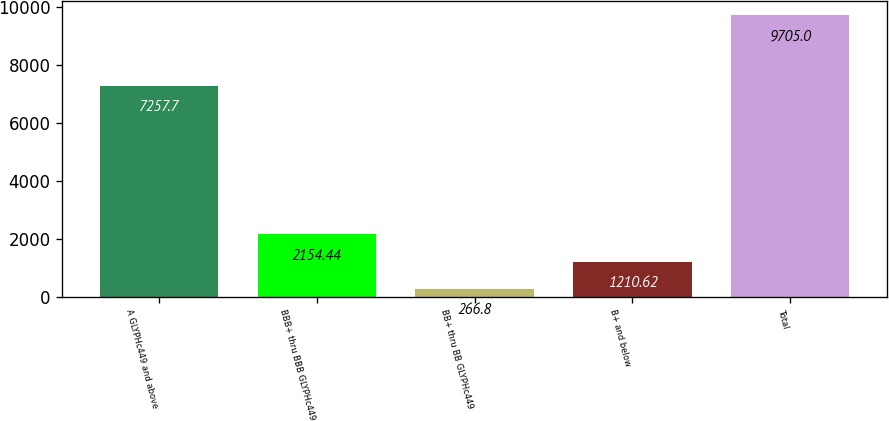<chart> <loc_0><loc_0><loc_500><loc_500><bar_chart><fcel>A GLYPHc449 and above<fcel>BBB+ thru BBB GLYPHc449<fcel>BB+ thru BB GLYPHc449<fcel>B+ and below<fcel>Total<nl><fcel>7257.7<fcel>2154.44<fcel>266.8<fcel>1210.62<fcel>9705<nl></chart> 